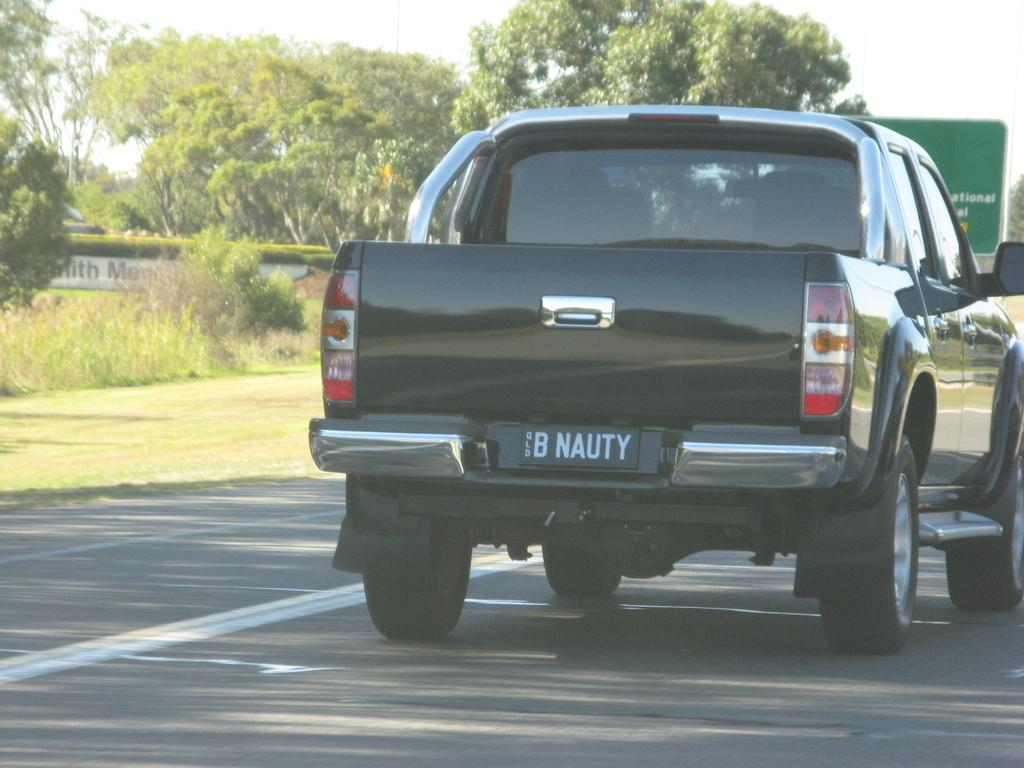What is the main subject of the image? There is a car in the image. Can you describe the car's appearance? The car is black in color. Where is the car located in the image? The car is on the road. What type of vegetation can be seen near the path in the image? There is grass near the path in the image. What other natural elements are present in the image? There are plants and trees in the image. What part of the natural environment is visible in the image? The sky is visible in the image. Can you hear the car's engine laugh in the image? There is no sound or indication of laughter in the image; it is a still photograph. 